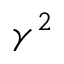Convert formula to latex. <formula><loc_0><loc_0><loc_500><loc_500>\gamma ^ { 2 }</formula> 